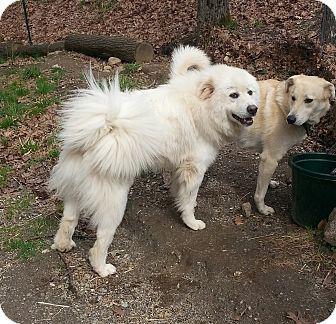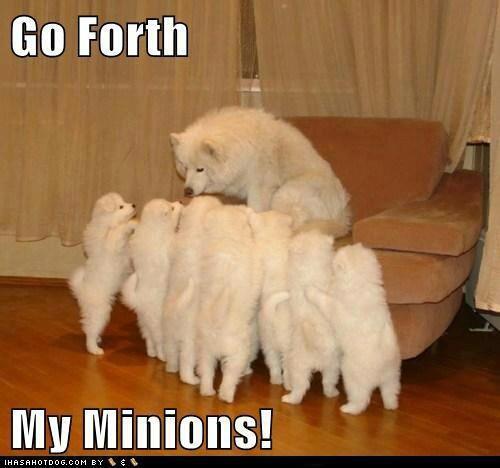The first image is the image on the left, the second image is the image on the right. For the images displayed, is the sentence "There are two dogs." factually correct? Answer yes or no. No. The first image is the image on the left, the second image is the image on the right. Examine the images to the left and right. Is the description "there are two dogs in the image pair" accurate? Answer yes or no. No. 